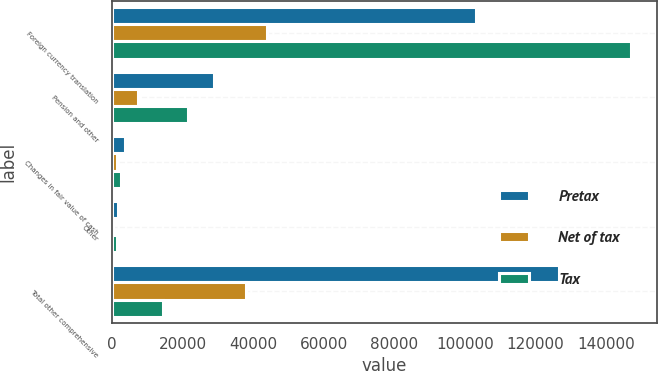Convert chart to OTSL. <chart><loc_0><loc_0><loc_500><loc_500><stacked_bar_chart><ecel><fcel>Foreign currency translation<fcel>Pension and other<fcel>Changes in fair value of cash<fcel>Other<fcel>Total other comprehensive<nl><fcel>Pretax<fcel>103214<fcel>28784<fcel>3678<fcel>1687<fcel>126633<nl><fcel>Net of tax<fcel>43842<fcel>7397<fcel>1287<fcel>202<fcel>37934<nl><fcel>Tax<fcel>147056<fcel>21387<fcel>2391<fcel>1485<fcel>14392<nl></chart> 